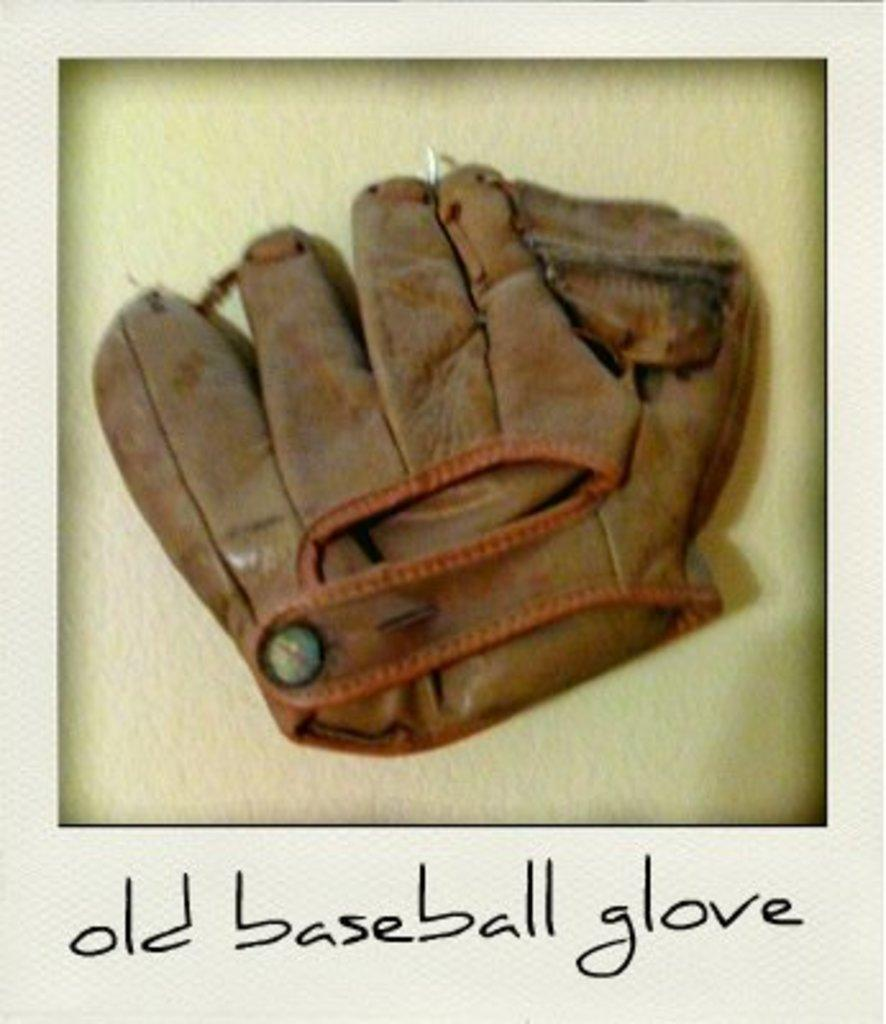What is the main subject of the image? The main subject of the image is a photo of an old baseball glove. What color is the baseball glove? The baseball glove is brown in color. What color is the background of the image? The background of the image is lime green. How does the cork in the image contribute to the overall design? There is no cork present in the image; it features a photo of an old baseball glove against a lime green background. 